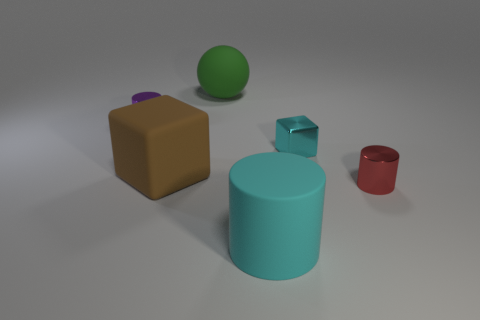Add 4 small green metal balls. How many objects exist? 10 Subtract all blocks. How many objects are left? 4 Add 5 metal cubes. How many metal cubes are left? 6 Add 4 balls. How many balls exist? 5 Subtract 1 brown blocks. How many objects are left? 5 Subtract all large blue matte spheres. Subtract all tiny things. How many objects are left? 3 